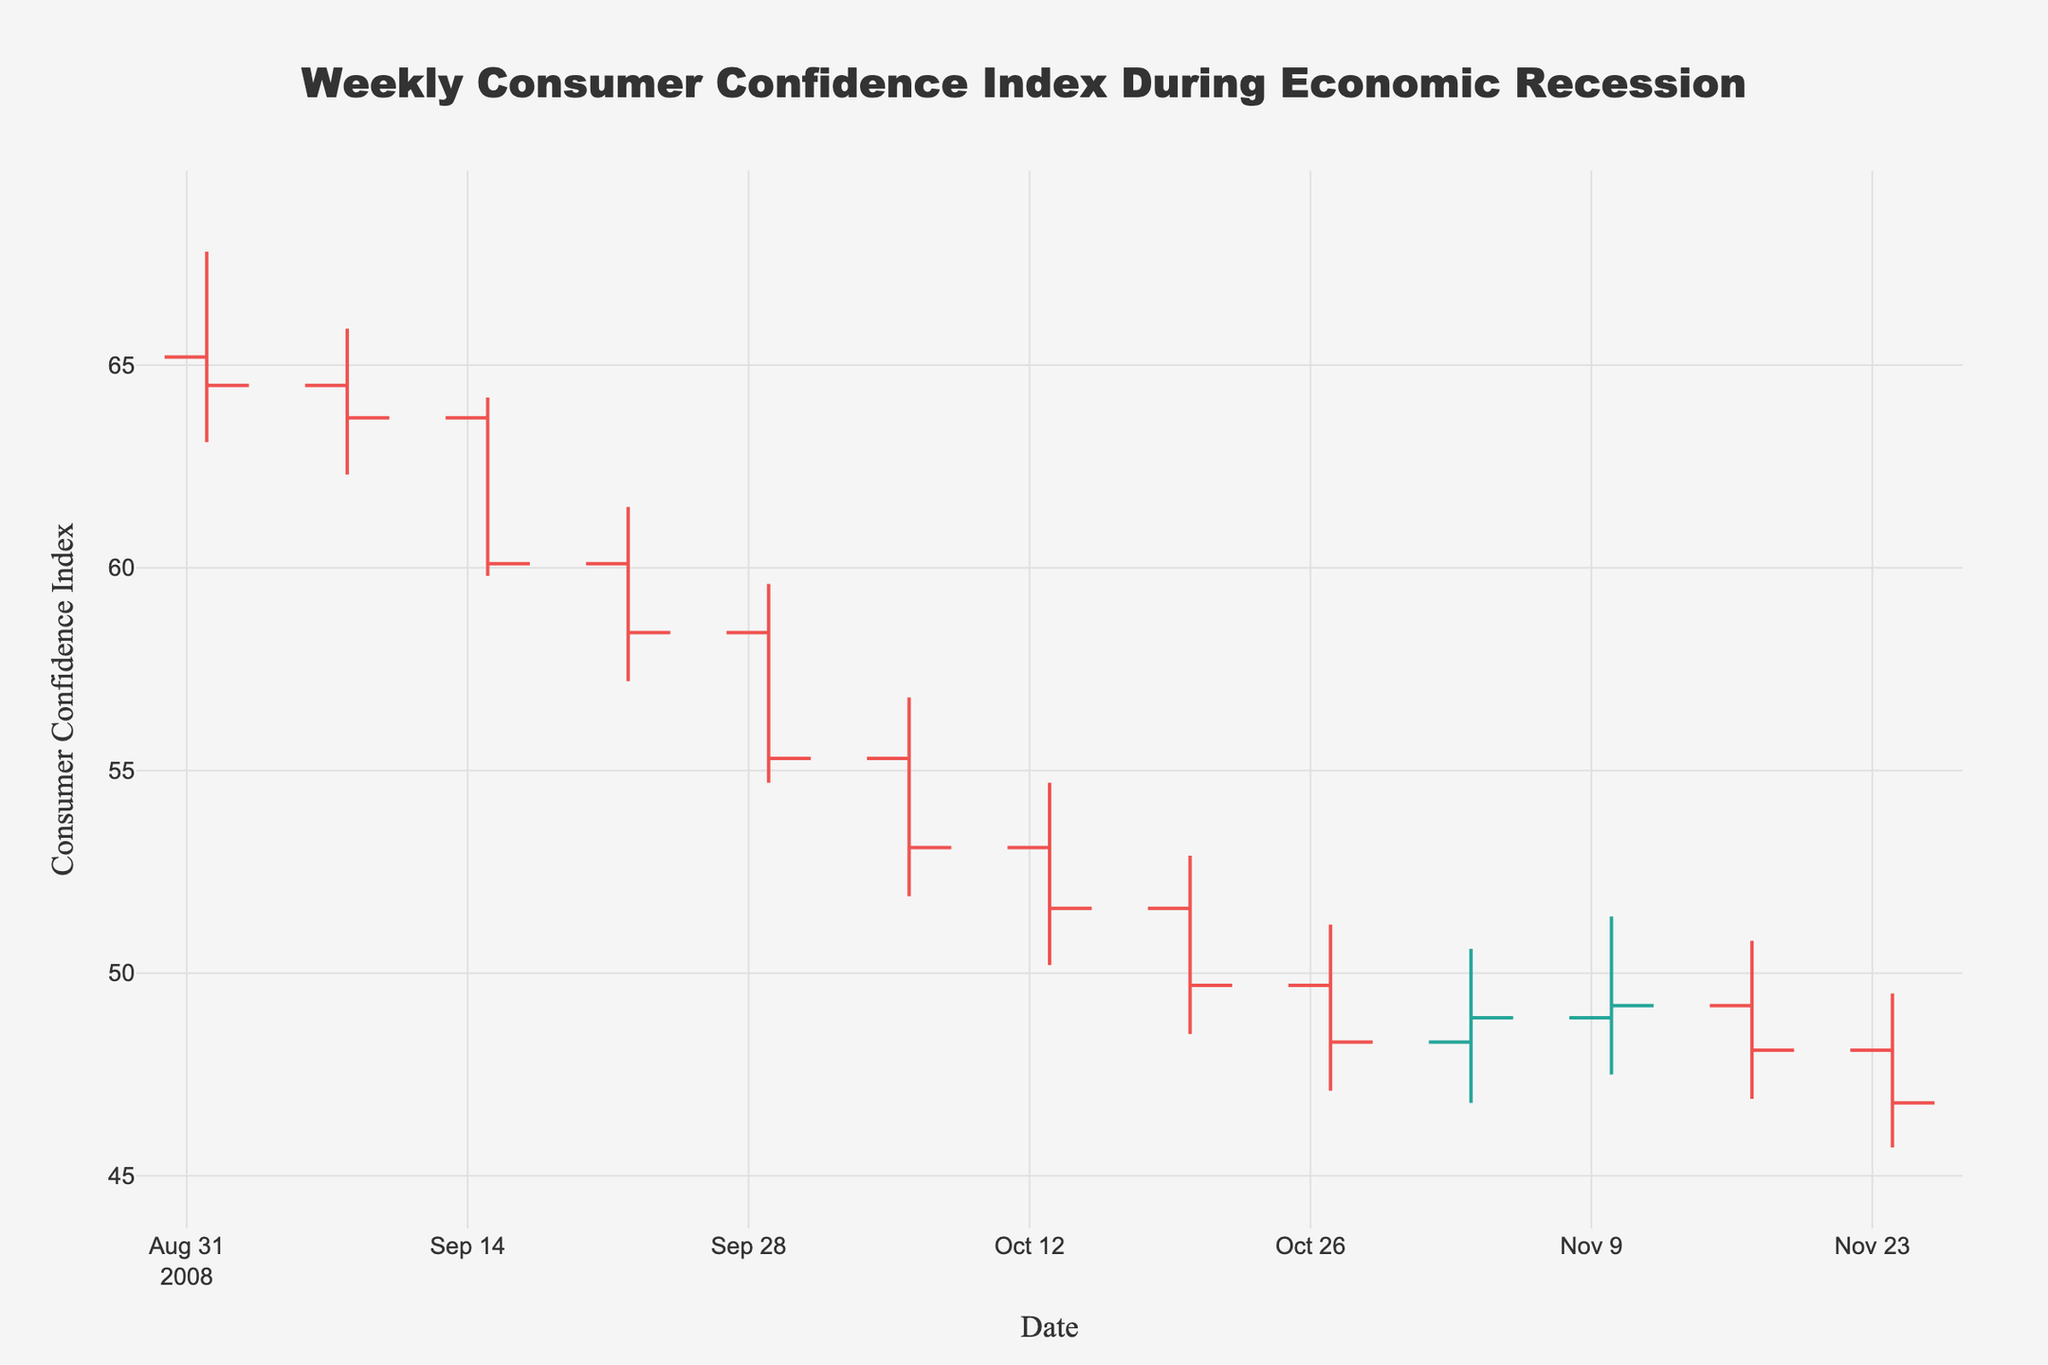What is the title of the figure? The title is usually at the top of the figure, easy to spot. It reads "Weekly Consumer Confidence Index During Economic Recession"
Answer: Weekly Consumer Confidence Index During Economic Recession What are the date ranges shown in the figure? To find the date range, look at the x-axis which represents dates. The first date is "2008-09-01" and the last date is "2008-11-24".
Answer: 2008-09-01 to 2008-11-24 What is the color of the increasing consumer confidence bars? Increasing bars are commonly assigned a specific color to differentiate them from decreasing bars. In this figure, the increasing bars are colored in a shade of green.
Answer: Green What is the highest consumer confidence index value recorded in this period and when? The highest index value can be found by looking at the highest point among the 'High' bars on the y-axis. It's 67.8 recorded on "2008-09-01".
Answer: 67.8 on 2008-09-01 During which week did the Consumer Confidence Index drop the most? For this, you need to look at the difference in the closing values between consecutive weeks. The biggest drop is between "2008-09-15" (60.1) and "2008-09-22" (58.4), which is a drop of 1.7 points.
Answer: 2008-09-15 to 2008-09-22 What week had the lowest closing value, and what was it? To determine this, identify the lowest close value on the y-axis. The lowest close value is 46.8 on "2008-11-24".
Answer: 46.8 on 2008-11-24 How many weeks did the Consumer Confidence Index end lower than it started? Counting each week where the Close value is lower than the Open value helps answer this. There are 8 such weeks.
Answer: 8 weeks What's the average closing index over the period shown? Compute the average of all close values by summing them up and dividing by the number of weeks: (64.5 + 63.7 + 60.1 + 58.4 + 55.3 + 53.1 + 51.6 + 49.7 + 48.3 + 48.9 + 49.2 + 48.1 + 46.8) / 13
Answer: 54.7 Compare the opening value of the first week to the closing value of the last week. Identify the first Open value (65.2 on 2008-09-01) and the last Close value (46.8 on 2008-11-24). Compare them: 65.2 is greater than 46.8.
Answer: 65.2 > 46.8 What is the range of the Consumer Confidence Index values for the week of 2008-10-06? Identify the High and Low values for that week: the High is 56.8 and the Low is 51.9, producing a range of 56.8 - 51.9 = 4.9 points.
Answer: 4.9 points 